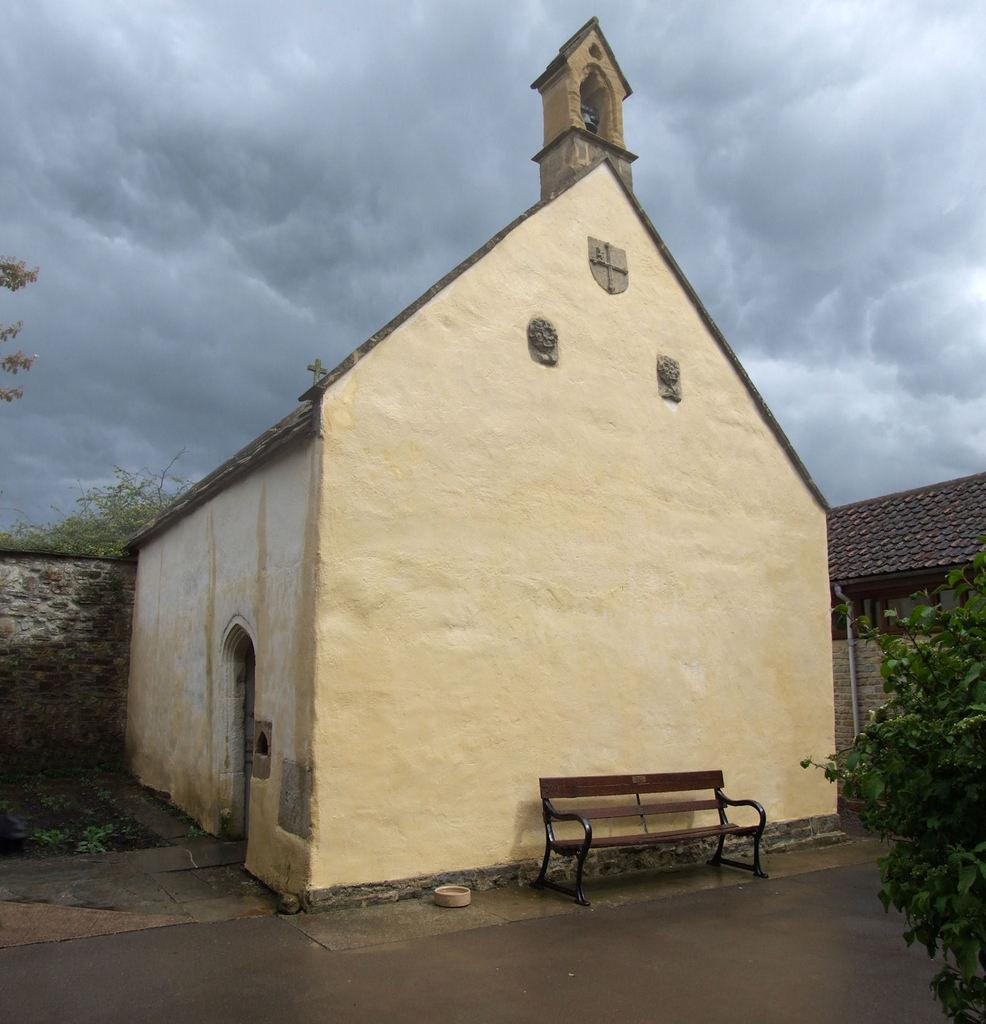What type of structures are visible in the image? There are houses in the image. What other natural elements can be seen in the image? There are trees in the image. Is there any seating visible in the image? Yes, there is a bench in the image. What object is on the ground in the image? There is a bowl on the ground in the image. How would you describe the weather in the image? The sky is cloudy in the image. Can you see any worms writing on the bench in the image? There are no worms or writing present on the bench in the image. What type of fuel is being used by the houses in the image? The image does not provide information about the type of fuel used by the houses. 